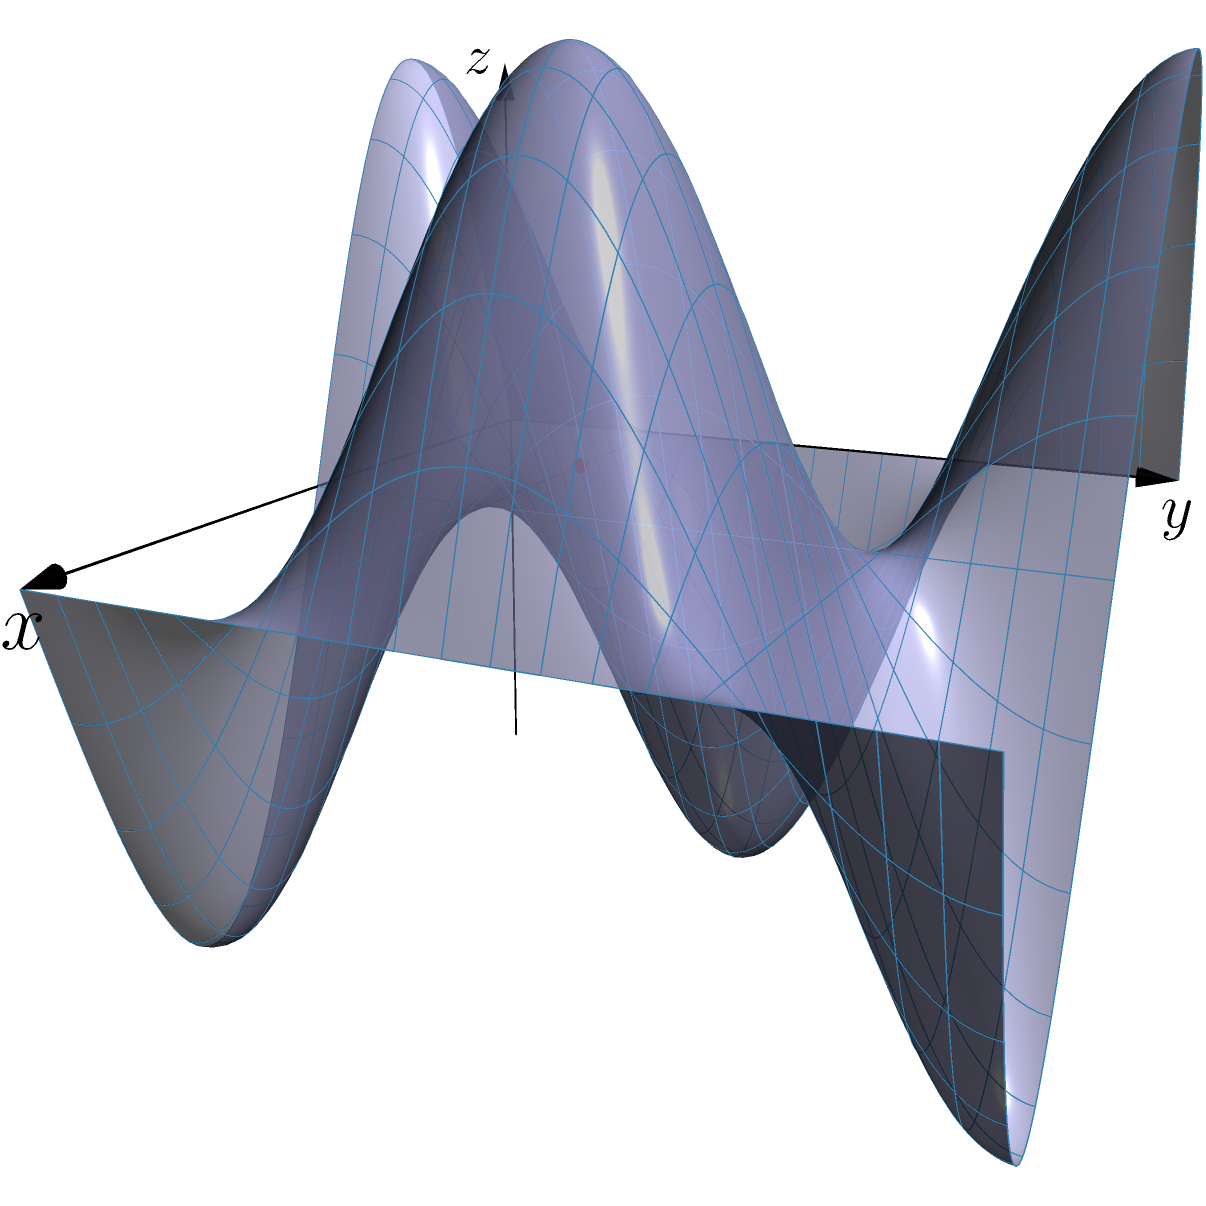A hand-drawn texture is being mapped onto a 3D surface defined by the function $z = \sin(2\pi x) \cos(2\pi y)$ for $0 \leq x,y \leq 1$. If a specific point on the texture is mapped to the coordinates $(0.25, 0.25)$ on the $xy$-plane, what is the $z$-coordinate of this point on the 3D surface? To find the $z$-coordinate, we need to follow these steps:

1) The surface is defined by the function $z = \sin(2\pi x) \cos(2\pi y)$.

2) We're given that the point is mapped to $(0.25, 0.25)$ on the $xy$-plane. So, $x = 0.25$ and $y = 0.25$.

3) Let's substitute these values into the function:

   $z = \sin(2\pi(0.25)) \cos(2\pi(0.25))$

4) Simplify the arguments:
   $z = \sin(\pi/2) \cos(\pi/2)$

5) Calculate:
   $\sin(\pi/2) = 1$
   $\cos(\pi/2) = 0$

6) Therefore:
   $z = 1 \cdot 0 = 0$

So, the $z$-coordinate of the point on the 3D surface is 0.
Answer: 0 